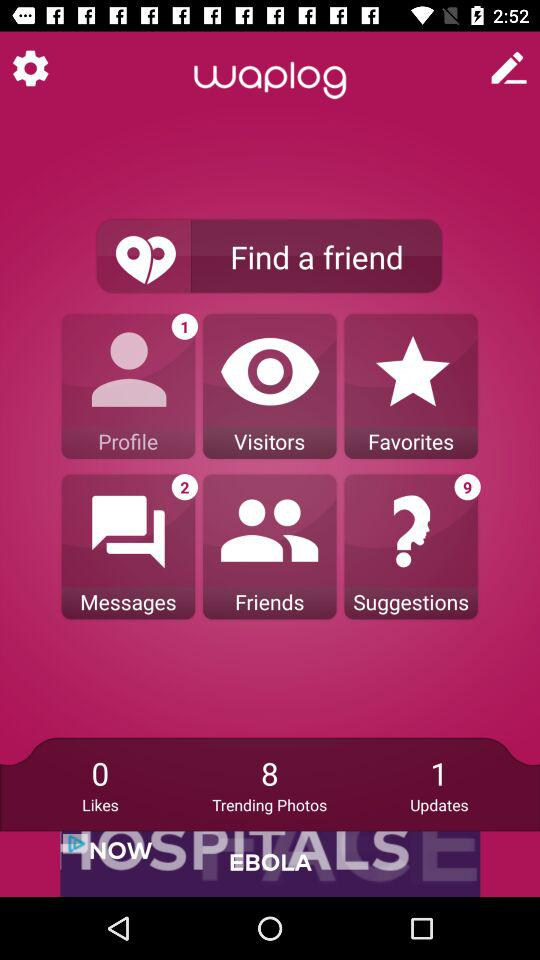How many trending photos are there? There are 8 trending photos. 